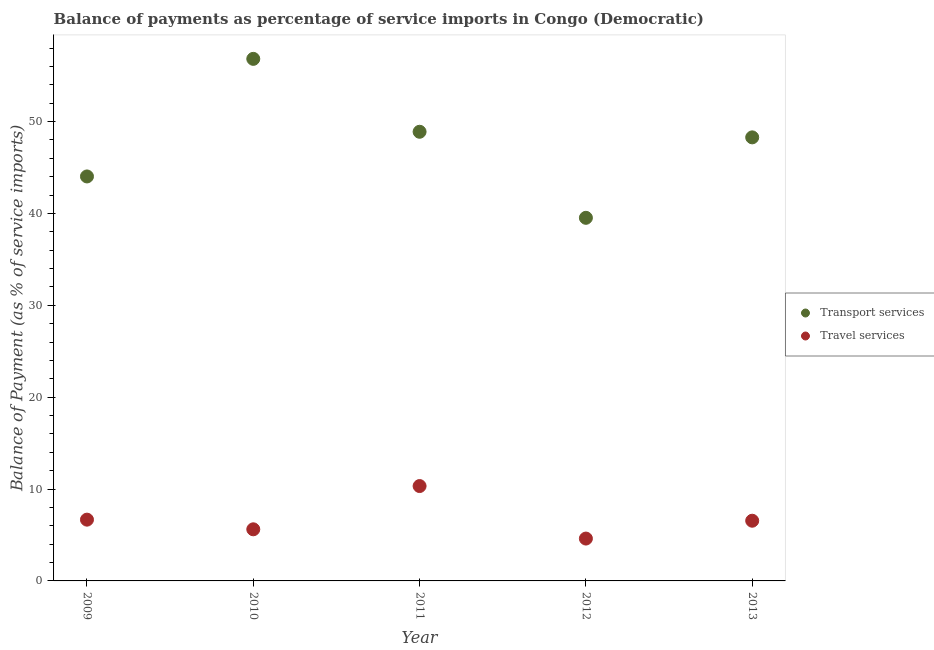Is the number of dotlines equal to the number of legend labels?
Give a very brief answer. Yes. What is the balance of payments of transport services in 2009?
Provide a short and direct response. 44.03. Across all years, what is the maximum balance of payments of transport services?
Offer a terse response. 56.83. Across all years, what is the minimum balance of payments of travel services?
Offer a very short reply. 4.61. In which year was the balance of payments of travel services maximum?
Offer a very short reply. 2011. What is the total balance of payments of transport services in the graph?
Provide a succinct answer. 237.55. What is the difference between the balance of payments of travel services in 2009 and that in 2010?
Ensure brevity in your answer.  1.05. What is the difference between the balance of payments of transport services in 2010 and the balance of payments of travel services in 2009?
Provide a succinct answer. 50.16. What is the average balance of payments of travel services per year?
Ensure brevity in your answer.  6.76. In the year 2013, what is the difference between the balance of payments of transport services and balance of payments of travel services?
Make the answer very short. 41.73. What is the ratio of the balance of payments of transport services in 2010 to that in 2012?
Your answer should be compact. 1.44. Is the balance of payments of transport services in 2009 less than that in 2011?
Provide a short and direct response. Yes. Is the difference between the balance of payments of transport services in 2009 and 2013 greater than the difference between the balance of payments of travel services in 2009 and 2013?
Offer a terse response. No. What is the difference between the highest and the second highest balance of payments of transport services?
Make the answer very short. 7.94. What is the difference between the highest and the lowest balance of payments of transport services?
Provide a short and direct response. 17.3. Does the balance of payments of transport services monotonically increase over the years?
Provide a succinct answer. No. How many dotlines are there?
Your answer should be compact. 2. How many years are there in the graph?
Your answer should be compact. 5. Does the graph contain any zero values?
Offer a terse response. No. Where does the legend appear in the graph?
Offer a very short reply. Center right. What is the title of the graph?
Ensure brevity in your answer.  Balance of payments as percentage of service imports in Congo (Democratic). What is the label or title of the Y-axis?
Provide a succinct answer. Balance of Payment (as % of service imports). What is the Balance of Payment (as % of service imports) in Transport services in 2009?
Keep it short and to the point. 44.03. What is the Balance of Payment (as % of service imports) of Travel services in 2009?
Your response must be concise. 6.67. What is the Balance of Payment (as % of service imports) in Transport services in 2010?
Keep it short and to the point. 56.83. What is the Balance of Payment (as % of service imports) in Travel services in 2010?
Offer a very short reply. 5.62. What is the Balance of Payment (as % of service imports) of Transport services in 2011?
Offer a terse response. 48.89. What is the Balance of Payment (as % of service imports) in Travel services in 2011?
Offer a very short reply. 10.33. What is the Balance of Payment (as % of service imports) in Transport services in 2012?
Give a very brief answer. 39.52. What is the Balance of Payment (as % of service imports) of Travel services in 2012?
Offer a very short reply. 4.61. What is the Balance of Payment (as % of service imports) in Transport services in 2013?
Ensure brevity in your answer.  48.28. What is the Balance of Payment (as % of service imports) of Travel services in 2013?
Your response must be concise. 6.55. Across all years, what is the maximum Balance of Payment (as % of service imports) in Transport services?
Your answer should be very brief. 56.83. Across all years, what is the maximum Balance of Payment (as % of service imports) in Travel services?
Make the answer very short. 10.33. Across all years, what is the minimum Balance of Payment (as % of service imports) of Transport services?
Your response must be concise. 39.52. Across all years, what is the minimum Balance of Payment (as % of service imports) of Travel services?
Your response must be concise. 4.61. What is the total Balance of Payment (as % of service imports) of Transport services in the graph?
Make the answer very short. 237.55. What is the total Balance of Payment (as % of service imports) of Travel services in the graph?
Give a very brief answer. 33.78. What is the difference between the Balance of Payment (as % of service imports) in Transport services in 2009 and that in 2010?
Provide a short and direct response. -12.8. What is the difference between the Balance of Payment (as % of service imports) in Travel services in 2009 and that in 2010?
Your response must be concise. 1.05. What is the difference between the Balance of Payment (as % of service imports) in Transport services in 2009 and that in 2011?
Ensure brevity in your answer.  -4.86. What is the difference between the Balance of Payment (as % of service imports) of Travel services in 2009 and that in 2011?
Your answer should be very brief. -3.66. What is the difference between the Balance of Payment (as % of service imports) in Transport services in 2009 and that in 2012?
Ensure brevity in your answer.  4.5. What is the difference between the Balance of Payment (as % of service imports) in Travel services in 2009 and that in 2012?
Offer a terse response. 2.06. What is the difference between the Balance of Payment (as % of service imports) in Transport services in 2009 and that in 2013?
Make the answer very short. -4.25. What is the difference between the Balance of Payment (as % of service imports) in Travel services in 2009 and that in 2013?
Keep it short and to the point. 0.12. What is the difference between the Balance of Payment (as % of service imports) in Transport services in 2010 and that in 2011?
Your answer should be very brief. 7.94. What is the difference between the Balance of Payment (as % of service imports) in Travel services in 2010 and that in 2011?
Provide a succinct answer. -4.71. What is the difference between the Balance of Payment (as % of service imports) in Transport services in 2010 and that in 2012?
Provide a short and direct response. 17.3. What is the difference between the Balance of Payment (as % of service imports) of Travel services in 2010 and that in 2012?
Make the answer very short. 1.01. What is the difference between the Balance of Payment (as % of service imports) of Transport services in 2010 and that in 2013?
Offer a terse response. 8.54. What is the difference between the Balance of Payment (as % of service imports) of Travel services in 2010 and that in 2013?
Make the answer very short. -0.93. What is the difference between the Balance of Payment (as % of service imports) in Transport services in 2011 and that in 2012?
Give a very brief answer. 9.37. What is the difference between the Balance of Payment (as % of service imports) of Travel services in 2011 and that in 2012?
Your response must be concise. 5.72. What is the difference between the Balance of Payment (as % of service imports) of Transport services in 2011 and that in 2013?
Your answer should be compact. 0.61. What is the difference between the Balance of Payment (as % of service imports) of Travel services in 2011 and that in 2013?
Ensure brevity in your answer.  3.77. What is the difference between the Balance of Payment (as % of service imports) of Transport services in 2012 and that in 2013?
Provide a succinct answer. -8.76. What is the difference between the Balance of Payment (as % of service imports) of Travel services in 2012 and that in 2013?
Offer a very short reply. -1.94. What is the difference between the Balance of Payment (as % of service imports) of Transport services in 2009 and the Balance of Payment (as % of service imports) of Travel services in 2010?
Your answer should be very brief. 38.41. What is the difference between the Balance of Payment (as % of service imports) in Transport services in 2009 and the Balance of Payment (as % of service imports) in Travel services in 2011?
Provide a succinct answer. 33.7. What is the difference between the Balance of Payment (as % of service imports) in Transport services in 2009 and the Balance of Payment (as % of service imports) in Travel services in 2012?
Offer a very short reply. 39.42. What is the difference between the Balance of Payment (as % of service imports) of Transport services in 2009 and the Balance of Payment (as % of service imports) of Travel services in 2013?
Ensure brevity in your answer.  37.47. What is the difference between the Balance of Payment (as % of service imports) in Transport services in 2010 and the Balance of Payment (as % of service imports) in Travel services in 2011?
Give a very brief answer. 46.5. What is the difference between the Balance of Payment (as % of service imports) in Transport services in 2010 and the Balance of Payment (as % of service imports) in Travel services in 2012?
Keep it short and to the point. 52.22. What is the difference between the Balance of Payment (as % of service imports) of Transport services in 2010 and the Balance of Payment (as % of service imports) of Travel services in 2013?
Your answer should be very brief. 50.27. What is the difference between the Balance of Payment (as % of service imports) of Transport services in 2011 and the Balance of Payment (as % of service imports) of Travel services in 2012?
Offer a very short reply. 44.28. What is the difference between the Balance of Payment (as % of service imports) in Transport services in 2011 and the Balance of Payment (as % of service imports) in Travel services in 2013?
Your answer should be very brief. 42.34. What is the difference between the Balance of Payment (as % of service imports) of Transport services in 2012 and the Balance of Payment (as % of service imports) of Travel services in 2013?
Ensure brevity in your answer.  32.97. What is the average Balance of Payment (as % of service imports) of Transport services per year?
Ensure brevity in your answer.  47.51. What is the average Balance of Payment (as % of service imports) of Travel services per year?
Keep it short and to the point. 6.76. In the year 2009, what is the difference between the Balance of Payment (as % of service imports) in Transport services and Balance of Payment (as % of service imports) in Travel services?
Make the answer very short. 37.36. In the year 2010, what is the difference between the Balance of Payment (as % of service imports) of Transport services and Balance of Payment (as % of service imports) of Travel services?
Offer a very short reply. 51.21. In the year 2011, what is the difference between the Balance of Payment (as % of service imports) in Transport services and Balance of Payment (as % of service imports) in Travel services?
Provide a short and direct response. 38.56. In the year 2012, what is the difference between the Balance of Payment (as % of service imports) in Transport services and Balance of Payment (as % of service imports) in Travel services?
Provide a short and direct response. 34.91. In the year 2013, what is the difference between the Balance of Payment (as % of service imports) in Transport services and Balance of Payment (as % of service imports) in Travel services?
Offer a terse response. 41.73. What is the ratio of the Balance of Payment (as % of service imports) in Transport services in 2009 to that in 2010?
Your answer should be very brief. 0.77. What is the ratio of the Balance of Payment (as % of service imports) in Travel services in 2009 to that in 2010?
Keep it short and to the point. 1.19. What is the ratio of the Balance of Payment (as % of service imports) in Transport services in 2009 to that in 2011?
Your response must be concise. 0.9. What is the ratio of the Balance of Payment (as % of service imports) of Travel services in 2009 to that in 2011?
Offer a very short reply. 0.65. What is the ratio of the Balance of Payment (as % of service imports) in Transport services in 2009 to that in 2012?
Give a very brief answer. 1.11. What is the ratio of the Balance of Payment (as % of service imports) of Travel services in 2009 to that in 2012?
Provide a succinct answer. 1.45. What is the ratio of the Balance of Payment (as % of service imports) in Transport services in 2009 to that in 2013?
Provide a short and direct response. 0.91. What is the ratio of the Balance of Payment (as % of service imports) of Travel services in 2009 to that in 2013?
Provide a succinct answer. 1.02. What is the ratio of the Balance of Payment (as % of service imports) of Transport services in 2010 to that in 2011?
Keep it short and to the point. 1.16. What is the ratio of the Balance of Payment (as % of service imports) of Travel services in 2010 to that in 2011?
Your answer should be compact. 0.54. What is the ratio of the Balance of Payment (as % of service imports) in Transport services in 2010 to that in 2012?
Provide a succinct answer. 1.44. What is the ratio of the Balance of Payment (as % of service imports) in Travel services in 2010 to that in 2012?
Give a very brief answer. 1.22. What is the ratio of the Balance of Payment (as % of service imports) in Transport services in 2010 to that in 2013?
Keep it short and to the point. 1.18. What is the ratio of the Balance of Payment (as % of service imports) of Travel services in 2010 to that in 2013?
Keep it short and to the point. 0.86. What is the ratio of the Balance of Payment (as % of service imports) of Transport services in 2011 to that in 2012?
Your response must be concise. 1.24. What is the ratio of the Balance of Payment (as % of service imports) in Travel services in 2011 to that in 2012?
Keep it short and to the point. 2.24. What is the ratio of the Balance of Payment (as % of service imports) of Transport services in 2011 to that in 2013?
Offer a terse response. 1.01. What is the ratio of the Balance of Payment (as % of service imports) in Travel services in 2011 to that in 2013?
Offer a terse response. 1.58. What is the ratio of the Balance of Payment (as % of service imports) in Transport services in 2012 to that in 2013?
Make the answer very short. 0.82. What is the ratio of the Balance of Payment (as % of service imports) of Travel services in 2012 to that in 2013?
Your answer should be compact. 0.7. What is the difference between the highest and the second highest Balance of Payment (as % of service imports) in Transport services?
Offer a very short reply. 7.94. What is the difference between the highest and the second highest Balance of Payment (as % of service imports) of Travel services?
Ensure brevity in your answer.  3.66. What is the difference between the highest and the lowest Balance of Payment (as % of service imports) in Transport services?
Ensure brevity in your answer.  17.3. What is the difference between the highest and the lowest Balance of Payment (as % of service imports) in Travel services?
Provide a short and direct response. 5.72. 